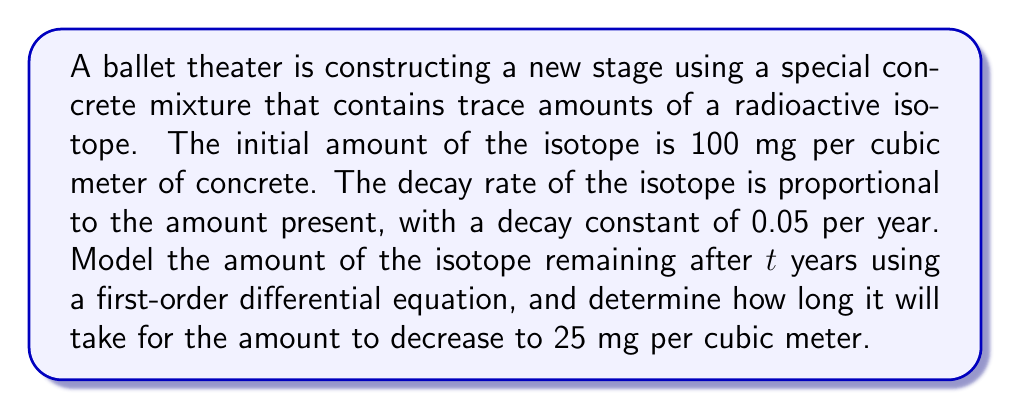Provide a solution to this math problem. Let's approach this step-by-step:

1) Let $A(t)$ be the amount of the isotope (in mg per cubic meter) at time $t$ (in years).

2) The rate of decay is proportional to the amount present. This can be expressed as:

   $$\frac{dA}{dt} = -kA$$

   where $k$ is the decay constant, given as 0.05 per year.

3) This is a first-order differential equation. The general solution is:

   $$A(t) = A_0e^{-kt}$$

   where $A_0$ is the initial amount.

4) Given the initial conditions: $A_0 = 100$ mg/m³ and $k = 0.05$ per year, we can write:

   $$A(t) = 100e^{-0.05t}$$

5) To find when the amount decreases to 25 mg/m³, we solve:

   $$25 = 100e^{-0.05t}$$

6) Dividing both sides by 100:

   $$0.25 = e^{-0.05t}$$

7) Taking the natural logarithm of both sides:

   $$\ln(0.25) = -0.05t$$

8) Solving for $t$:

   $$t = \frac{\ln(0.25)}{-0.05} = \frac{-1.386}{-0.05} = 27.72$$

Therefore, it will take approximately 27.72 years for the amount to decrease to 25 mg per cubic meter.
Answer: The amount of the isotope at time $t$ is given by $A(t) = 100e^{-0.05t}$ mg/m³, and it will take approximately 27.72 years for the amount to decrease to 25 mg/m³. 